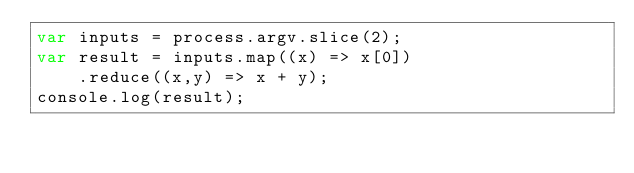Convert code to text. <code><loc_0><loc_0><loc_500><loc_500><_JavaScript_>var inputs = process.argv.slice(2);
var result = inputs.map((x) => x[0])
		.reduce((x,y) => x + y);
console.log(result);</code> 